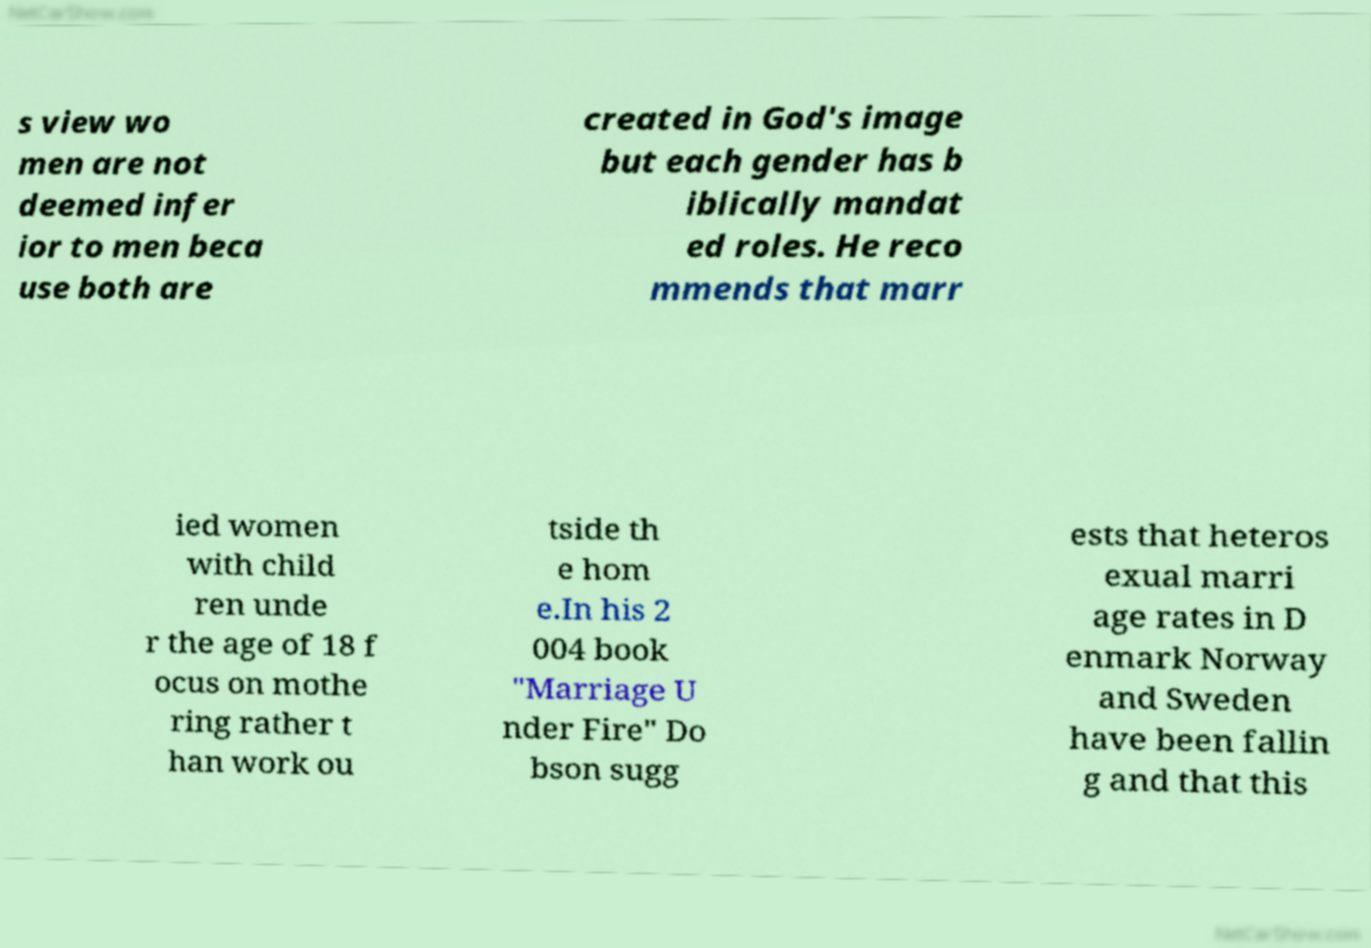Could you extract and type out the text from this image? s view wo men are not deemed infer ior to men beca use both are created in God's image but each gender has b iblically mandat ed roles. He reco mmends that marr ied women with child ren unde r the age of 18 f ocus on mothe ring rather t han work ou tside th e hom e.In his 2 004 book "Marriage U nder Fire" Do bson sugg ests that heteros exual marri age rates in D enmark Norway and Sweden have been fallin g and that this 